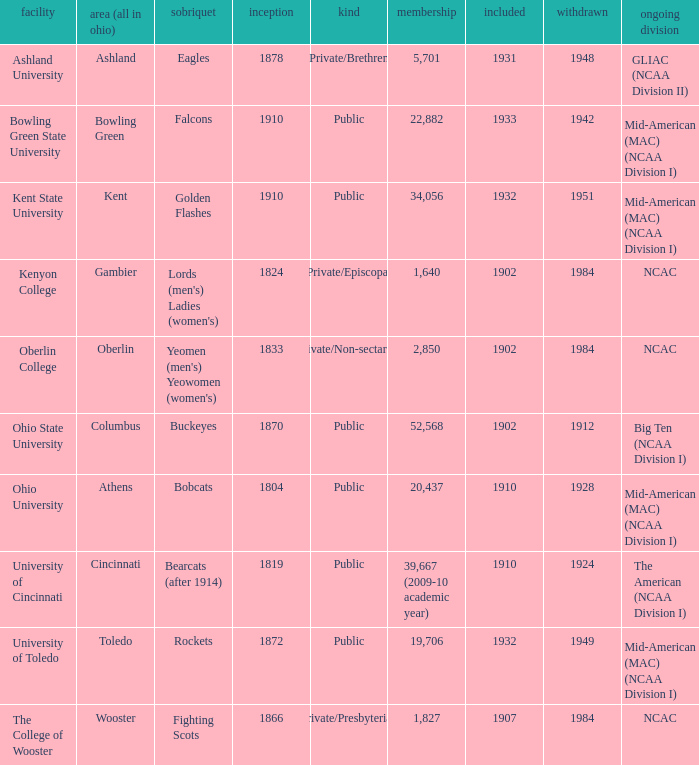What is the type of institution in Kent State University? Public. 